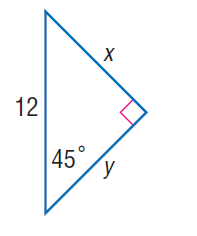Question: Find x.
Choices:
A. 2 \sqrt { 2 }
B. 3 \sqrt { 2 }
C. 5 \sqrt { 2 }
D. 6 \sqrt { 2 }
Answer with the letter. Answer: D 